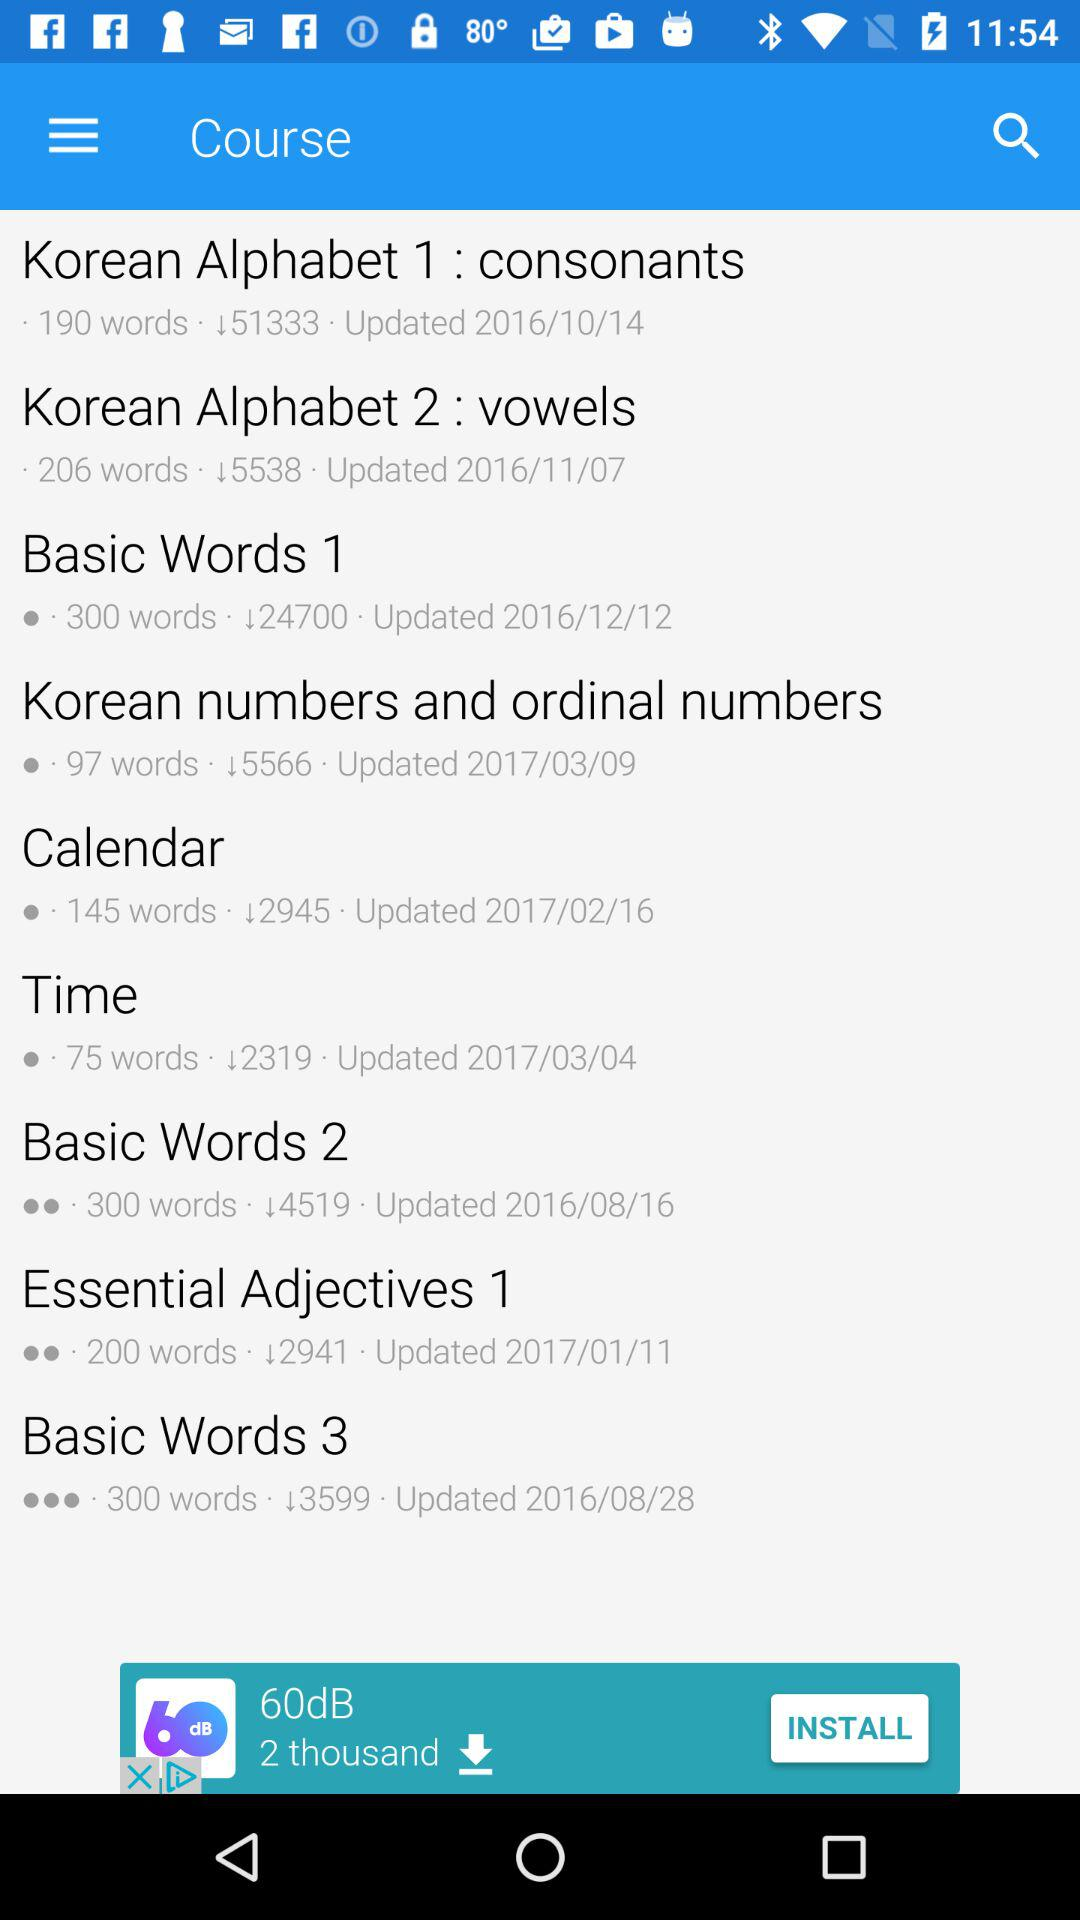How many words are there in the "Korean Alphabet 1"? There are 190 words in the "Korean Alphabet 1". 